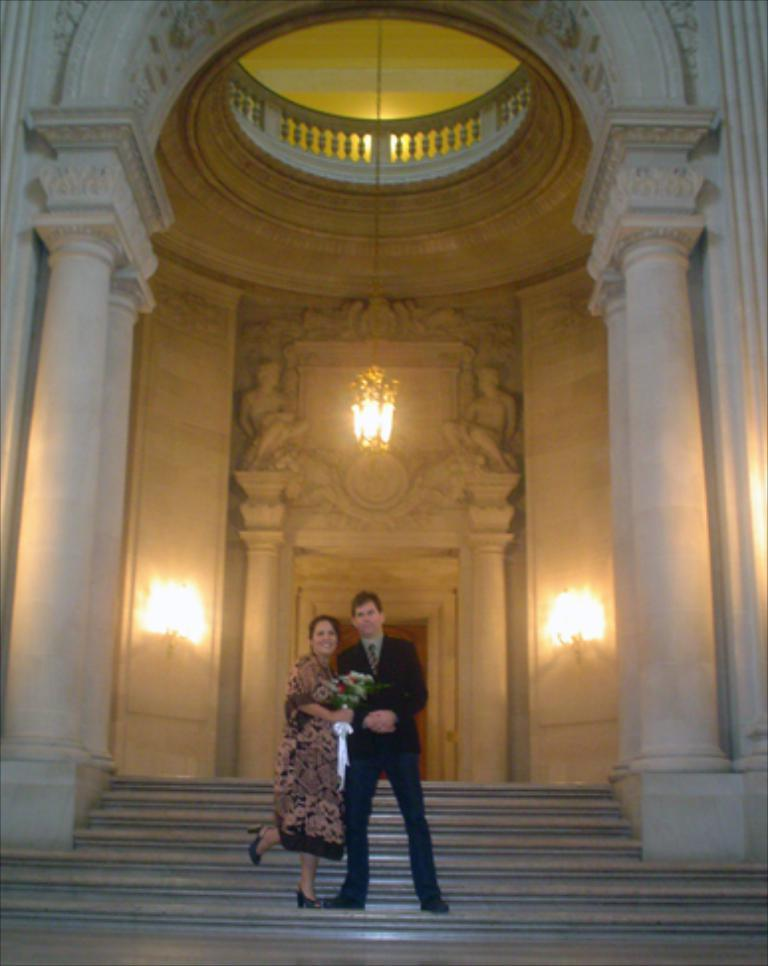Who is present in the image? There is a man and a woman in the image. What are the man and woman holding? Both the man and woman are holding flowers. What can be seen on both sides of the image? There are lamps on the right side and the left side of the image. What type of spy equipment can be seen in the hands of the man in the image? There is no spy equipment visible in the hands of the man in the image; he is holding flowers. 